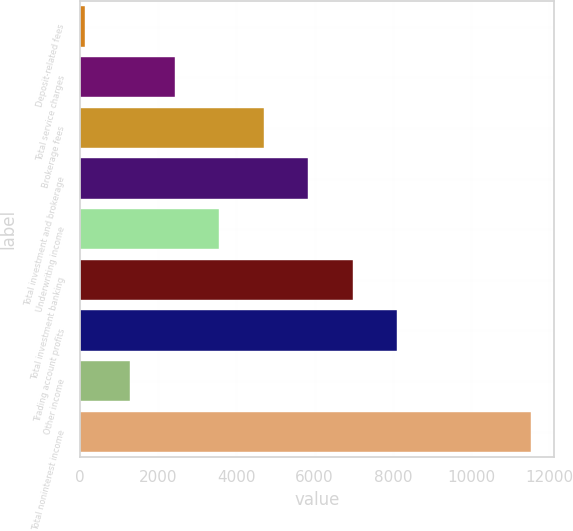Convert chart to OTSL. <chart><loc_0><loc_0><loc_500><loc_500><bar_chart><fcel>Deposit-related fees<fcel>Total service charges<fcel>Brokerage fees<fcel>Total investment and brokerage<fcel>Underwriting income<fcel>Total investment banking<fcel>Trading account profits<fcel>Other income<fcel>Total noninterest income<nl><fcel>143<fcel>2421<fcel>4699<fcel>5838<fcel>3560<fcel>6977<fcel>8116<fcel>1282<fcel>11533<nl></chart> 